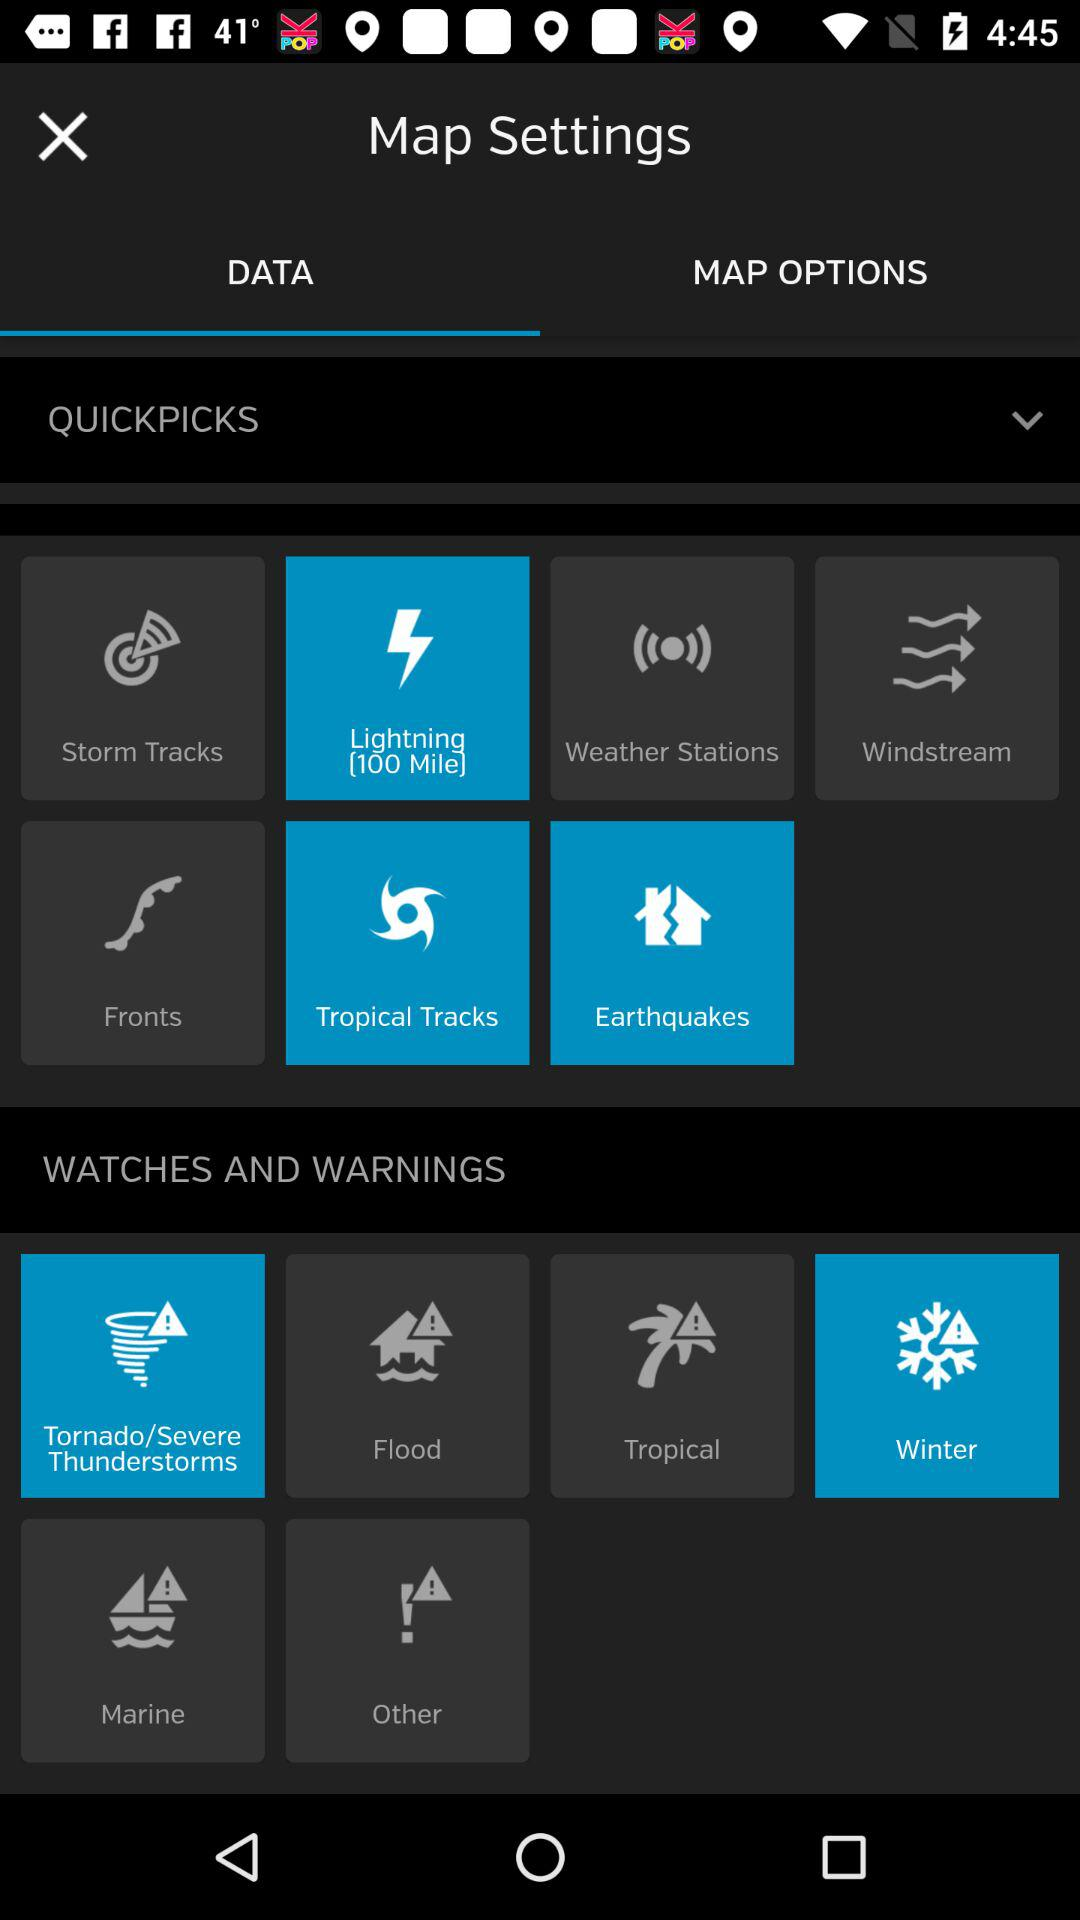Which maps are available in "MAP OPTIONS"?
When the provided information is insufficient, respond with <no answer>. <no answer> 